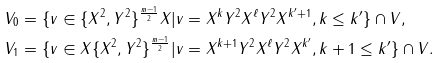Convert formula to latex. <formula><loc_0><loc_0><loc_500><loc_500>V _ { 0 } & = \{ v \in \{ X ^ { 2 } , Y ^ { 2 } \} ^ { \frac { m - 1 } { 2 } } X | v = X ^ { k } Y ^ { 2 } X ^ { \ell } Y ^ { 2 } X ^ { k ^ { \prime } + 1 } , k \leq k ^ { \prime } \} \cap V , \\ V _ { 1 } & = \{ v \in X \{ X ^ { 2 } , Y ^ { 2 } \} ^ { \frac { m - 1 } { 2 } } | v = X ^ { k + 1 } Y ^ { 2 } X ^ { \ell } Y ^ { 2 } X ^ { k ^ { \prime } } , k + 1 \leq k ^ { \prime } \} \cap V .</formula> 